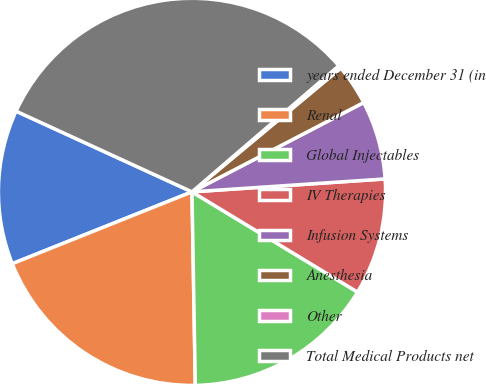<chart> <loc_0><loc_0><loc_500><loc_500><pie_chart><fcel>years ended December 31 (in<fcel>Renal<fcel>Global Injectables<fcel>IV Therapies<fcel>Infusion Systems<fcel>Anesthesia<fcel>Other<fcel>Total Medical Products net<nl><fcel>12.9%<fcel>19.22%<fcel>16.06%<fcel>9.73%<fcel>6.57%<fcel>3.41%<fcel>0.25%<fcel>31.86%<nl></chart> 